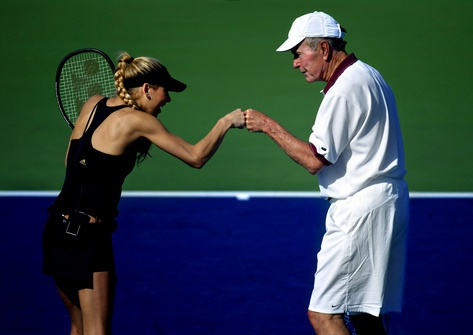Describe the objects in this image and their specific colors. I can see people in darkgreen, white, navy, darkgray, and brown tones, people in darkgreen, black, gray, maroon, and tan tones, tennis racket in darkgreen and black tones, and cell phone in black, gray, and darkgreen tones in this image. 